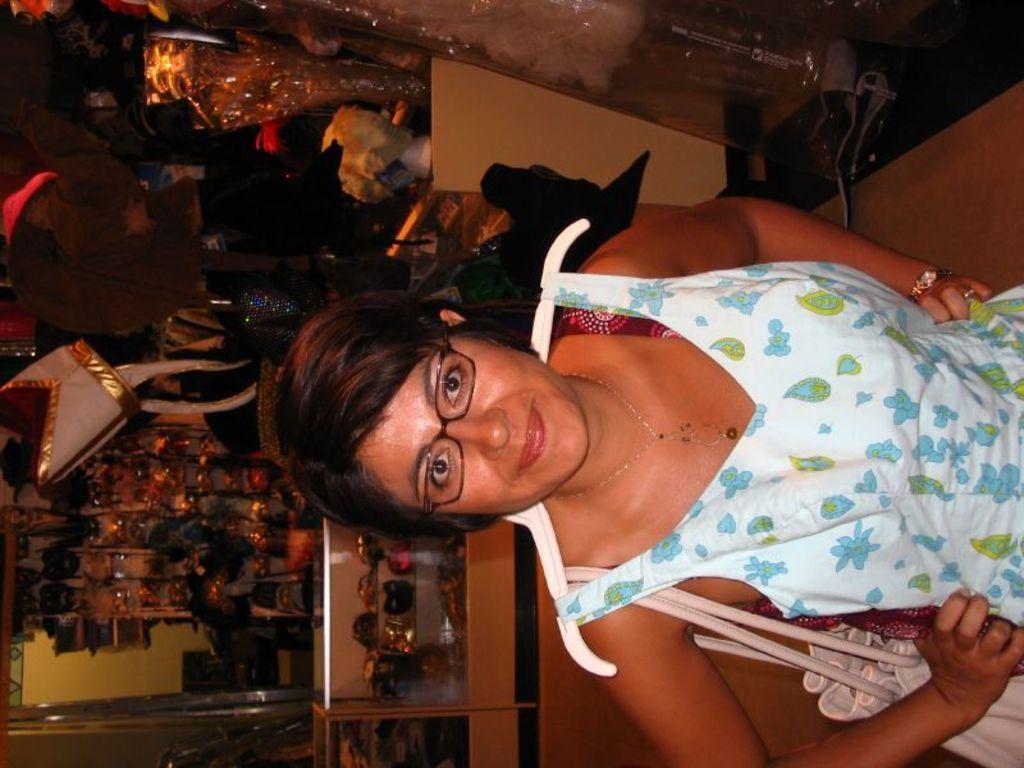Describe this image in one or two sentences. In this image I see a woman who is wearing white, blue, green and red color dress and I see that she is smiling and she is wearing a bag and in the background I see many things and I see the floor. 